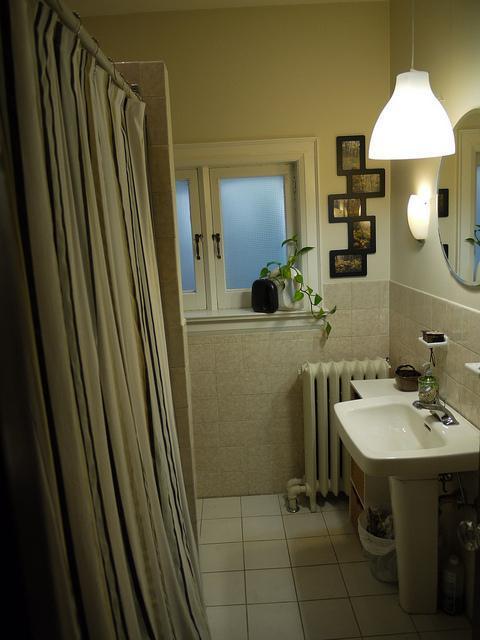How many lights are over the sink?
Give a very brief answer. 2. How many people are wearing a red shirt?
Give a very brief answer. 0. 